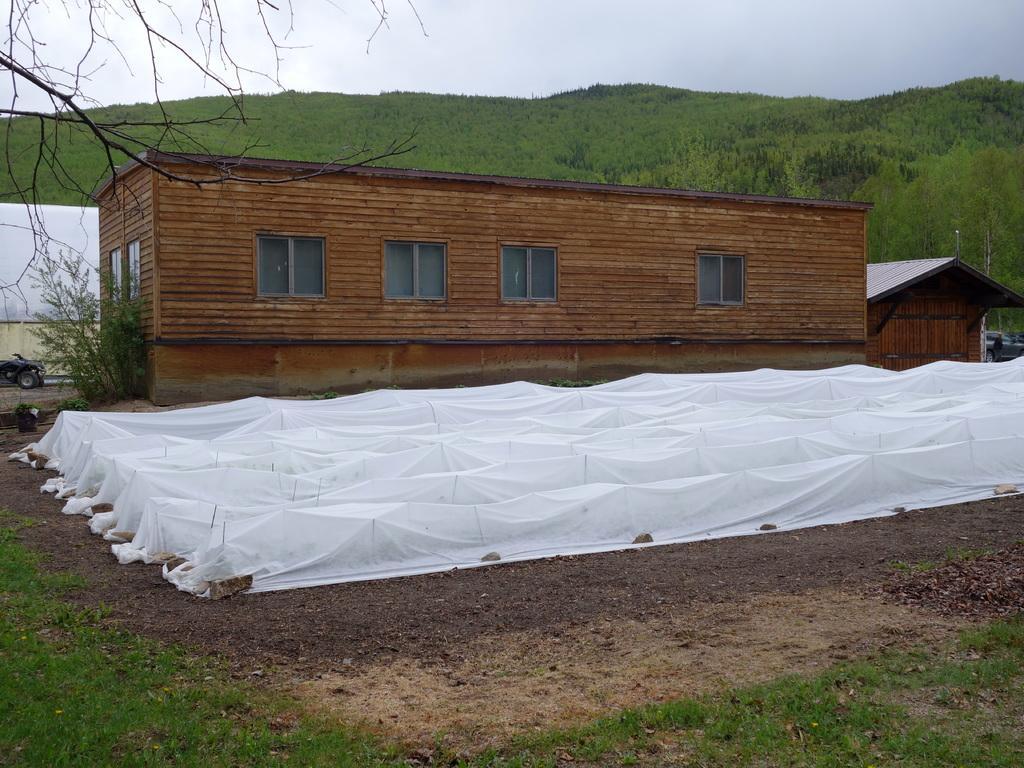Could you give a brief overview of what you see in this image? In the background of the image there is a house with windows. At the bottom of the image there is grass. There is a white color cover. In the background of the image there are mountains,trees and sky. 